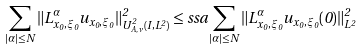Convert formula to latex. <formula><loc_0><loc_0><loc_500><loc_500>\sum _ { | \alpha | \leq N } \| L _ { x _ { 0 } , \xi _ { 0 } } ^ { \alpha } u _ { x _ { 0 } , \xi _ { 0 } } \| _ { U ^ { 2 } _ { A , \nu } ( I , L ^ { 2 } ) } ^ { 2 } \leq s s a \sum _ { | \alpha | \leq N } \| L _ { x _ { 0 } , \xi _ { 0 } } ^ { \alpha } u _ { x _ { 0 } , \xi _ { 0 } } ( 0 ) \| _ { L ^ { 2 } } ^ { 2 }</formula> 